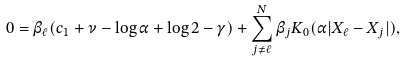Convert formula to latex. <formula><loc_0><loc_0><loc_500><loc_500>0 = \beta _ { \ell } ( c _ { 1 } + \nu - \log \alpha + \log 2 - \gamma ) + \sum _ { j \neq \ell } ^ { N } \beta _ { j } K _ { 0 } ( \alpha | { X } _ { \ell } - { X } _ { j } | ) ,</formula> 